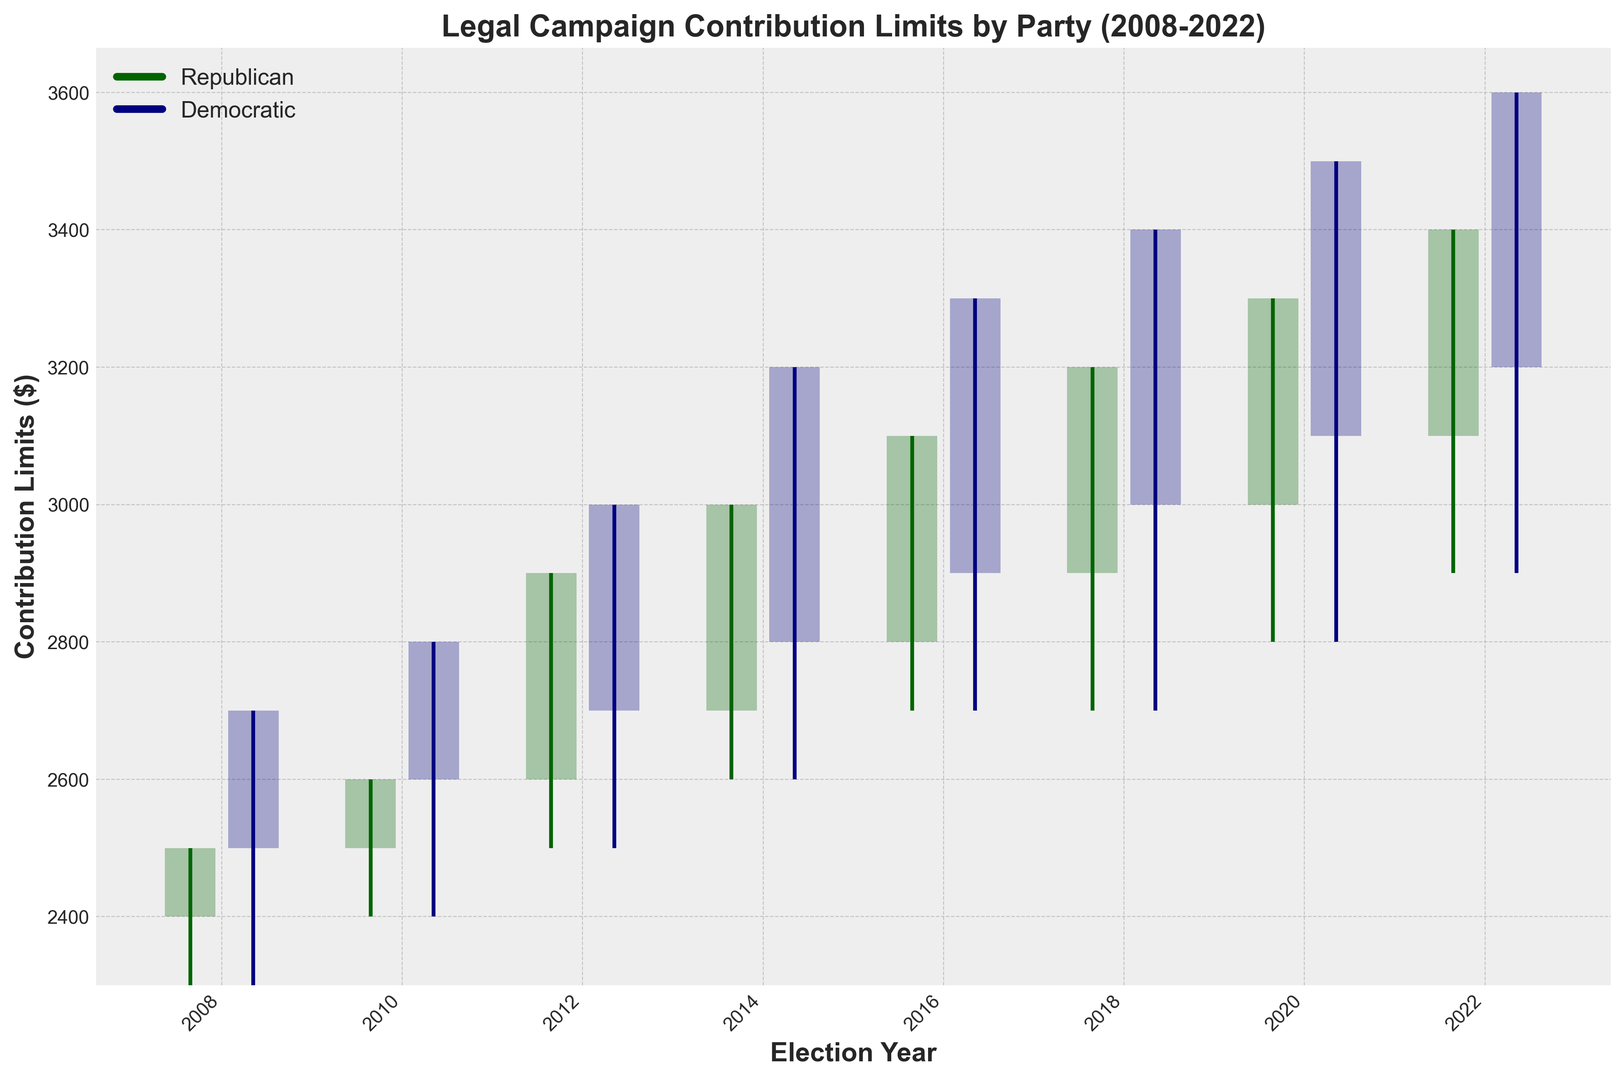Which party had the highest closing limit in 2022? To find the highest closing limit in 2022, compare the closing limits for both the Republican and Democratic parties in that year. For Republicans, it was $3100, and for Democrats, it was $3200.
Answer: Democratic By how much did the upper limit for Democrats change from 2008 to 2022? The upper limit for Democrats in 2008 was $2700, and in 2022 it was $3600. Subtract the two values to find the change: $3600 - $2700 = $900.
Answer: $900 What is the difference between the highest upper limit for Republicans and Democrats across all years? The highest upper limit for Republicans across all years is $3400 in 2022. The highest upper limit for Democrats is $3600 in 2022. The difference is $3600 - $3400 = $200.
Answer: $200 In which year did the Democrats surpass Republicans in the upper limit for the first time? Evaluate each year sequentially to determine the first instance where the Democratic upper limit is greater than the Republican upper limit. In 2008, the Democratic upper limit is $2700, and the Republican upper limit is $2500. Therefore, the Democrats surpassed Republicans in 2008.
Answer: 2008 What is the overall trend for the closing limits of both parties from 2008 to 2022? Observe the closing limits for both parties each year. Both parties show an increasing trend in their closing limits from 2008 ($2400 for Republicans, $2500 for Democrats) to 2022 ($3100 for Republicans, $3200 for Democrats).
Answer: Increasing trend Compare the variance of the upper limits between the two parties in 2020. Which party had a larger variability? In 2020, the upper limit for Republicans is $3300 and for Democrats is $3500. The variability is the difference between the lower and upper limits. For Republicans, variability is $3300 - $2800 = $500. For Democrats, variability is $3500 - $2800 = $700. Democrats had a larger variability.
Answer: Democratic Which party had a consistently higher lower limit from 2008 to 2022? Compare the lower limits for both parties across each year. Both parties had equal lower limits every year from 2008 to 2022.
Answer: Neither, they were equal What is the difference in the median closing limits of the two parties over the years shown? Calculate the median closing limit for both parties between 2008 to 2022. For Republicans: $2400, $2500, $2600, $2700, $2800, $2900, $3000, $3100 (median is $\frac{2600 + 2700}{2} = 2650$). For Democrats: $2500, $2600, $2700, $2800, $2900, $3000, $3100, $3200 (median is $\frac{2700 + 2800}{2} = 2750$). The difference is $2750 - $2650 = $100.
Answer: $100 Which election year had the smallest difference between the opening and closing limits for Democrats? Compare the difference between the opening and closing limits for Democrats in each year. The smallest difference occurs when $OpeningLimit - ClosingLimit$ is minimized. In 2018, the difference is $3000 - 2700 = $300$.
Answer: 2018 